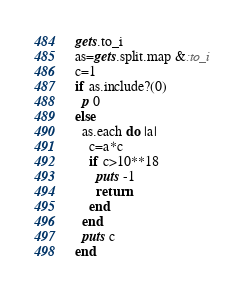Convert code to text. <code><loc_0><loc_0><loc_500><loc_500><_Ruby_>gets.to_i
as=gets.split.map &:to_i
c=1
if as.include?(0)
  p 0
else
  as.each do |a|
    c=a*c
    if c>10**18
      puts -1
      return
    end
  end
  puts c
end
</code> 